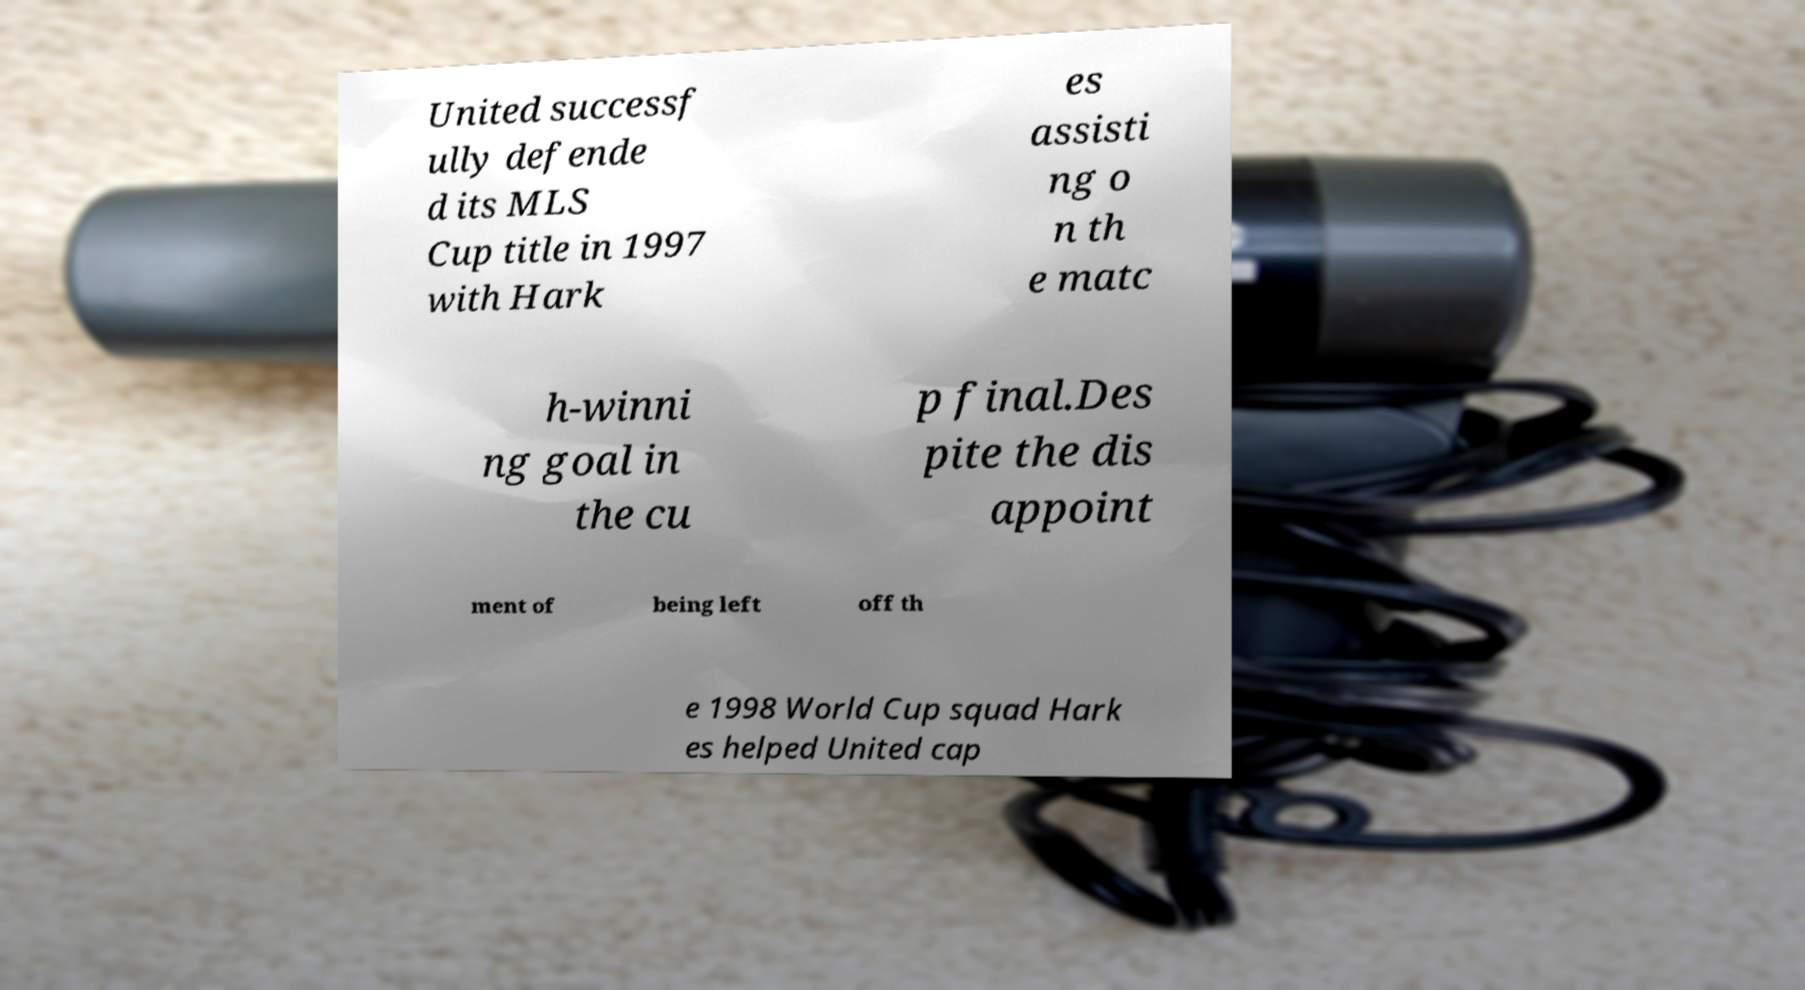Could you assist in decoding the text presented in this image and type it out clearly? United successf ully defende d its MLS Cup title in 1997 with Hark es assisti ng o n th e matc h-winni ng goal in the cu p final.Des pite the dis appoint ment of being left off th e 1998 World Cup squad Hark es helped United cap 